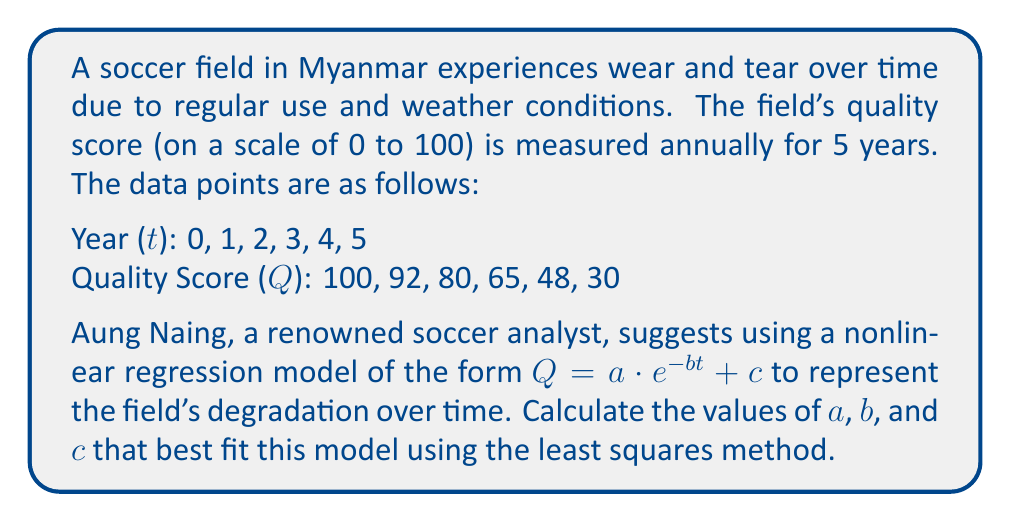Teach me how to tackle this problem. To solve this problem, we'll use the nonlinear least squares method to fit the exponential decay model $Q = a \cdot e^{-bt} + c$ to the given data.

Step 1: Set up the sum of squared residuals (SSR) function:
$$SSR = \sum_{i=1}^{6} [Q_i - (a \cdot e^{-bt_i} + c)]^2$$

Step 2: To minimize SSR, we need to find the partial derivatives with respect to $a$, $b$, and $c$ and set them equal to zero:

$$\frac{\partial SSR}{\partial a} = -2\sum_{i=1}^{6} [Q_i - (a \cdot e^{-bt_i} + c)] \cdot e^{-bt_i} = 0$$
$$\frac{\partial SSR}{\partial b} = 2\sum_{i=1}^{6} [Q_i - (a \cdot e^{-bt_i} + c)] \cdot at_ie^{-bt_i} = 0$$
$$\frac{\partial SSR}{\partial c} = -2\sum_{i=1}^{6} [Q_i - (a \cdot e^{-bt_i} + c)] = 0$$

Step 3: Solve this system of nonlinear equations numerically using an optimization algorithm such as Levenberg-Marquardt or Gauss-Newton method. This step typically requires computational software.

Step 4: Using a numerical solver (e.g., Python's scipy.optimize.curve_fit), we obtain the following approximate values:

$a \approx 71.5$
$b \approx 0.324$
$c \approx 28.5$

Step 5: Verify the fit by calculating the predicted values and comparing them to the actual data:

$$Q = 71.5 \cdot e^{-0.324t} + 28.5$$

t = 0: Q ≈ 100.0
t = 1: Q ≈ 91.9
t = 2: Q ≈ 80.0
t = 3: Q ≈ 65.5
t = 4: Q ≈ 49.5
t = 5: Q ≈ 32.9

These values closely match the given data points, confirming a good fit.
Answer: $Q = 71.5 \cdot e^{-0.324t} + 28.5$ 